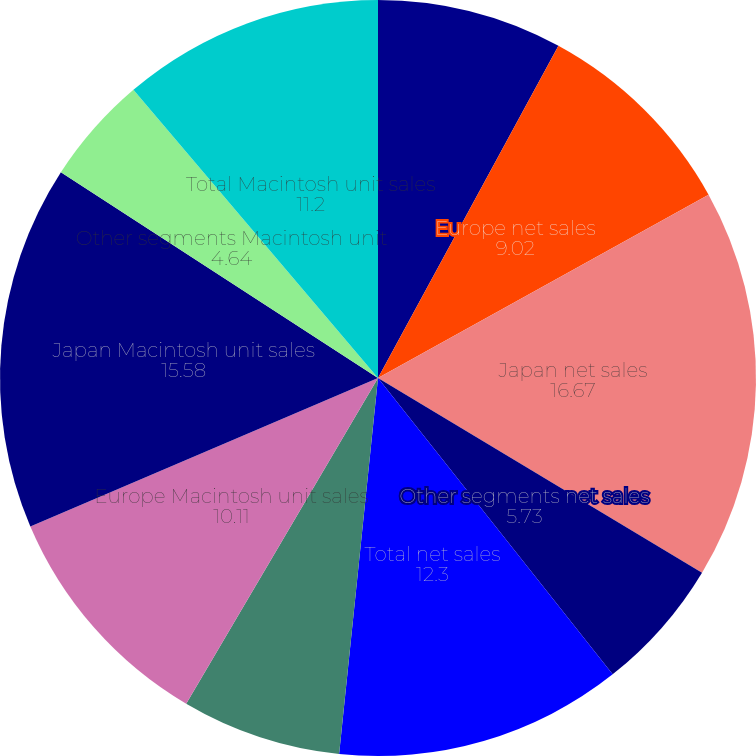Convert chart. <chart><loc_0><loc_0><loc_500><loc_500><pie_chart><fcel>Americas net sales<fcel>Europe net sales<fcel>Japan net sales<fcel>Other segments net sales<fcel>Total net sales<fcel>Americas Macintosh unit sales<fcel>Europe Macintosh unit sales<fcel>Japan Macintosh unit sales<fcel>Other segments Macintosh unit<fcel>Total Macintosh unit sales<nl><fcel>7.92%<fcel>9.02%<fcel>16.67%<fcel>5.73%<fcel>12.3%<fcel>6.83%<fcel>10.11%<fcel>15.58%<fcel>4.64%<fcel>11.2%<nl></chart> 